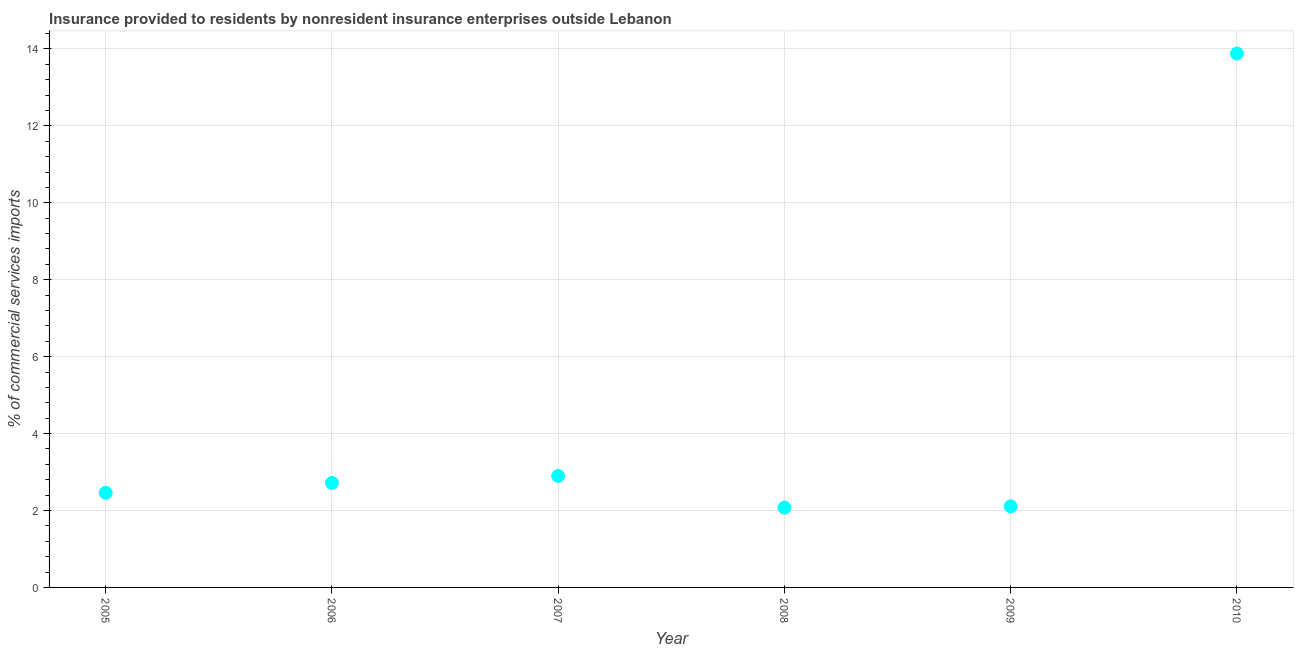What is the insurance provided by non-residents in 2010?
Make the answer very short. 13.88. Across all years, what is the maximum insurance provided by non-residents?
Keep it short and to the point. 13.88. Across all years, what is the minimum insurance provided by non-residents?
Ensure brevity in your answer.  2.07. In which year was the insurance provided by non-residents maximum?
Provide a succinct answer. 2010. In which year was the insurance provided by non-residents minimum?
Provide a succinct answer. 2008. What is the sum of the insurance provided by non-residents?
Provide a short and direct response. 26.14. What is the difference between the insurance provided by non-residents in 2005 and 2010?
Offer a terse response. -11.42. What is the average insurance provided by non-residents per year?
Your answer should be very brief. 4.36. What is the median insurance provided by non-residents?
Your answer should be compact. 2.59. In how many years, is the insurance provided by non-residents greater than 10.4 %?
Your answer should be compact. 1. Do a majority of the years between 2007 and 2005 (inclusive) have insurance provided by non-residents greater than 7.6 %?
Provide a succinct answer. No. What is the ratio of the insurance provided by non-residents in 2005 to that in 2010?
Provide a short and direct response. 0.18. Is the insurance provided by non-residents in 2009 less than that in 2010?
Your answer should be very brief. Yes. What is the difference between the highest and the second highest insurance provided by non-residents?
Your answer should be compact. 10.98. What is the difference between the highest and the lowest insurance provided by non-residents?
Your answer should be compact. 11.81. In how many years, is the insurance provided by non-residents greater than the average insurance provided by non-residents taken over all years?
Make the answer very short. 1. How many years are there in the graph?
Make the answer very short. 6. Are the values on the major ticks of Y-axis written in scientific E-notation?
Provide a short and direct response. No. What is the title of the graph?
Provide a short and direct response. Insurance provided to residents by nonresident insurance enterprises outside Lebanon. What is the label or title of the X-axis?
Offer a terse response. Year. What is the label or title of the Y-axis?
Your answer should be very brief. % of commercial services imports. What is the % of commercial services imports in 2005?
Provide a short and direct response. 2.46. What is the % of commercial services imports in 2006?
Provide a succinct answer. 2.72. What is the % of commercial services imports in 2007?
Offer a terse response. 2.9. What is the % of commercial services imports in 2008?
Provide a short and direct response. 2.07. What is the % of commercial services imports in 2009?
Give a very brief answer. 2.11. What is the % of commercial services imports in 2010?
Offer a terse response. 13.88. What is the difference between the % of commercial services imports in 2005 and 2006?
Your response must be concise. -0.26. What is the difference between the % of commercial services imports in 2005 and 2007?
Offer a very short reply. -0.44. What is the difference between the % of commercial services imports in 2005 and 2008?
Offer a very short reply. 0.39. What is the difference between the % of commercial services imports in 2005 and 2009?
Your answer should be very brief. 0.35. What is the difference between the % of commercial services imports in 2005 and 2010?
Your answer should be very brief. -11.42. What is the difference between the % of commercial services imports in 2006 and 2007?
Keep it short and to the point. -0.18. What is the difference between the % of commercial services imports in 2006 and 2008?
Your response must be concise. 0.64. What is the difference between the % of commercial services imports in 2006 and 2009?
Your response must be concise. 0.61. What is the difference between the % of commercial services imports in 2006 and 2010?
Your answer should be compact. -11.16. What is the difference between the % of commercial services imports in 2007 and 2008?
Your response must be concise. 0.82. What is the difference between the % of commercial services imports in 2007 and 2009?
Provide a short and direct response. 0.79. What is the difference between the % of commercial services imports in 2007 and 2010?
Your answer should be very brief. -10.98. What is the difference between the % of commercial services imports in 2008 and 2009?
Give a very brief answer. -0.03. What is the difference between the % of commercial services imports in 2008 and 2010?
Your answer should be very brief. -11.81. What is the difference between the % of commercial services imports in 2009 and 2010?
Your response must be concise. -11.77. What is the ratio of the % of commercial services imports in 2005 to that in 2006?
Provide a succinct answer. 0.91. What is the ratio of the % of commercial services imports in 2005 to that in 2007?
Provide a succinct answer. 0.85. What is the ratio of the % of commercial services imports in 2005 to that in 2008?
Your answer should be very brief. 1.19. What is the ratio of the % of commercial services imports in 2005 to that in 2009?
Provide a succinct answer. 1.17. What is the ratio of the % of commercial services imports in 2005 to that in 2010?
Make the answer very short. 0.18. What is the ratio of the % of commercial services imports in 2006 to that in 2007?
Your answer should be compact. 0.94. What is the ratio of the % of commercial services imports in 2006 to that in 2008?
Offer a terse response. 1.31. What is the ratio of the % of commercial services imports in 2006 to that in 2009?
Make the answer very short. 1.29. What is the ratio of the % of commercial services imports in 2006 to that in 2010?
Offer a terse response. 0.2. What is the ratio of the % of commercial services imports in 2007 to that in 2008?
Keep it short and to the point. 1.4. What is the ratio of the % of commercial services imports in 2007 to that in 2009?
Your response must be concise. 1.38. What is the ratio of the % of commercial services imports in 2007 to that in 2010?
Provide a short and direct response. 0.21. What is the ratio of the % of commercial services imports in 2008 to that in 2010?
Keep it short and to the point. 0.15. What is the ratio of the % of commercial services imports in 2009 to that in 2010?
Keep it short and to the point. 0.15. 